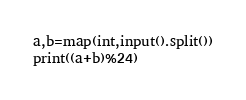<code> <loc_0><loc_0><loc_500><loc_500><_Python_>a,b=map(int,input().split())
print((a+b)%24)</code> 